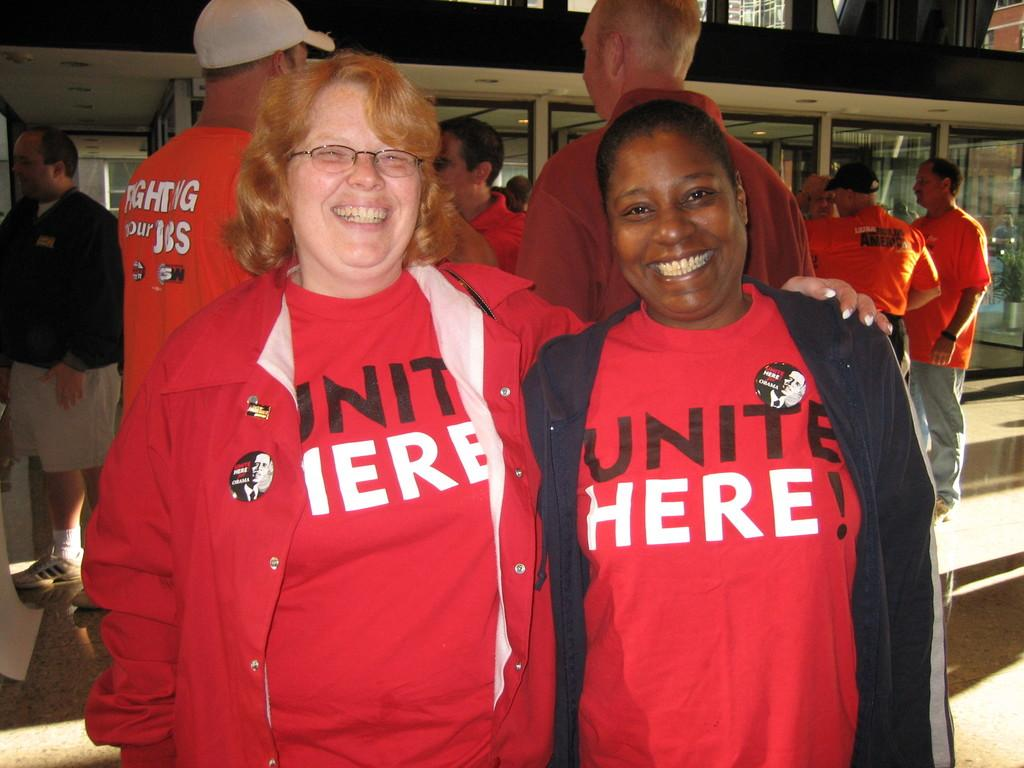<image>
Give a short and clear explanation of the subsequent image. Two women wearing red Unite Here! shirts are smiling for a photo. 